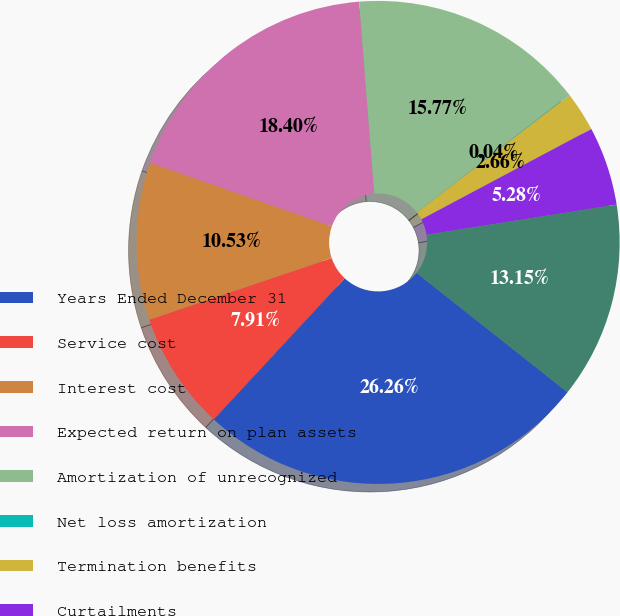<chart> <loc_0><loc_0><loc_500><loc_500><pie_chart><fcel>Years Ended December 31<fcel>Service cost<fcel>Interest cost<fcel>Expected return on plan assets<fcel>Amortization of unrecognized<fcel>Net loss amortization<fcel>Termination benefits<fcel>Curtailments<fcel>Net periodic benefit cost<nl><fcel>26.26%<fcel>7.91%<fcel>10.53%<fcel>18.4%<fcel>15.77%<fcel>0.04%<fcel>2.66%<fcel>5.28%<fcel>13.15%<nl></chart> 